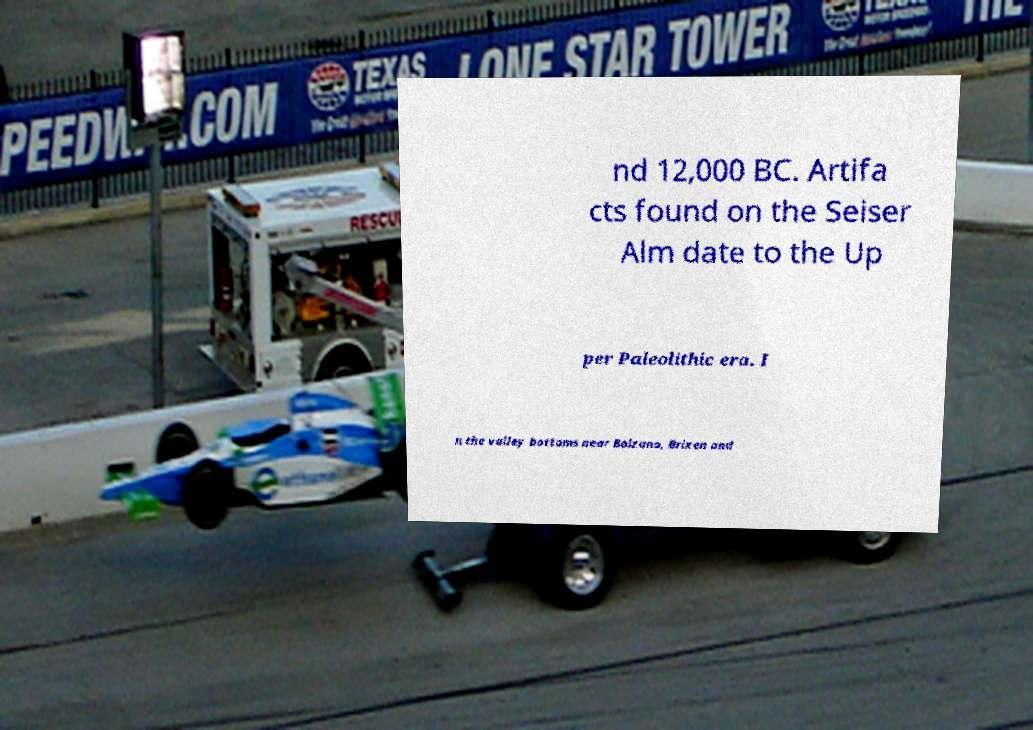There's text embedded in this image that I need extracted. Can you transcribe it verbatim? nd 12,000 BC. Artifa cts found on the Seiser Alm date to the Up per Paleolithic era. I n the valley bottoms near Bolzano, Brixen and 